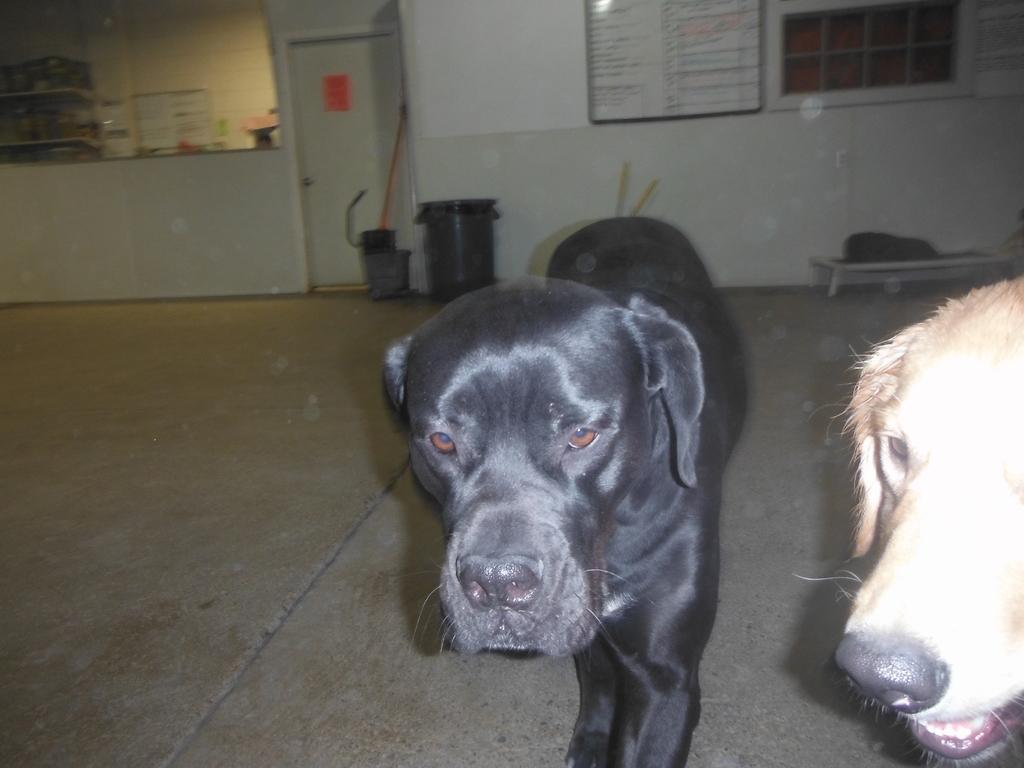How would you summarize this image in a sentence or two? In this image we can see two dogs. In the back there is a wall, door. On the wall there is a board with something written. Also there is a dustbin and some other items. 